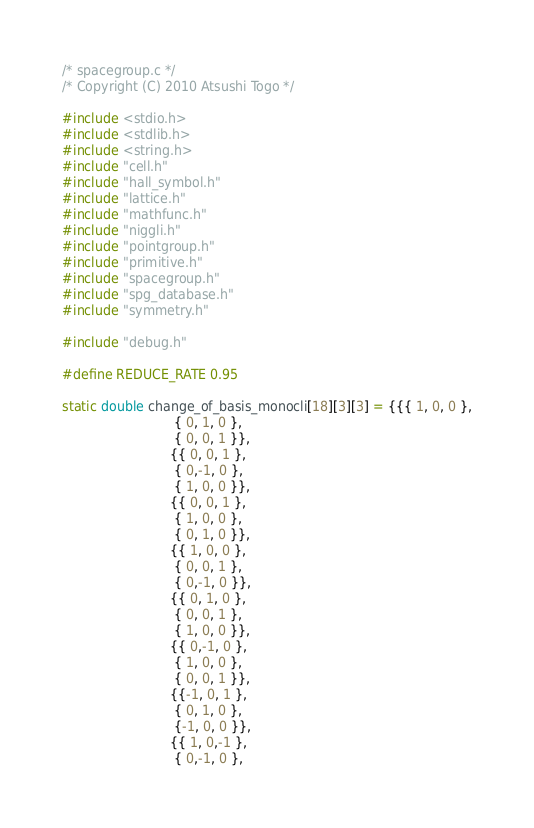Convert code to text. <code><loc_0><loc_0><loc_500><loc_500><_C_>/* spacegroup.c */
/* Copyright (C) 2010 Atsushi Togo */

#include <stdio.h>
#include <stdlib.h>
#include <string.h>
#include "cell.h"
#include "hall_symbol.h"
#include "lattice.h"
#include "mathfunc.h"
#include "niggli.h"
#include "pointgroup.h"
#include "primitive.h"
#include "spacegroup.h"
#include "spg_database.h"
#include "symmetry.h"

#include "debug.h"

#define REDUCE_RATE 0.95

static double change_of_basis_monocli[18][3][3] = {{{ 1, 0, 0 },
						    { 0, 1, 0 },
						    { 0, 0, 1 }},
						   {{ 0, 0, 1 },
						    { 0,-1, 0 },
						    { 1, 0, 0 }},
						   {{ 0, 0, 1 },
						    { 1, 0, 0 },
						    { 0, 1, 0 }},
						   {{ 1, 0, 0 },
						    { 0, 0, 1 },
						    { 0,-1, 0 }},
						   {{ 0, 1, 0 },
						    { 0, 0, 1 },
						    { 1, 0, 0 }},
						   {{ 0,-1, 0 },
						    { 1, 0, 0 },
						    { 0, 0, 1 }},
						   {{-1, 0, 1 },
						    { 0, 1, 0 },
						    {-1, 0, 0 }},
						   {{ 1, 0,-1 },
						    { 0,-1, 0 },</code> 